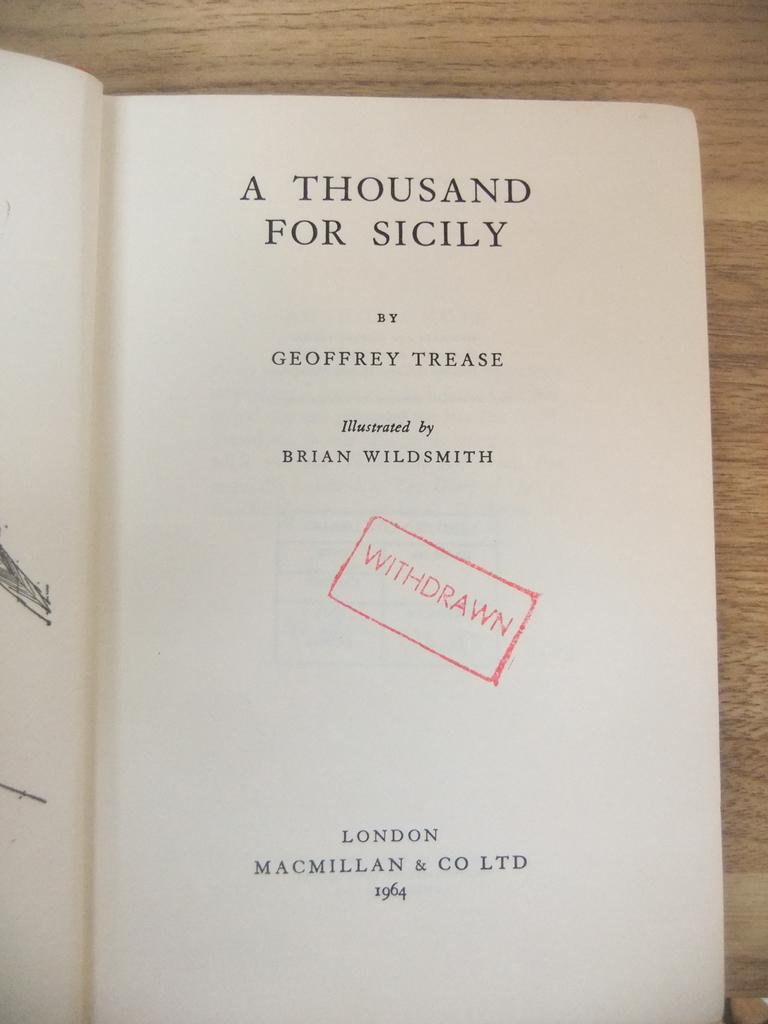<image>
Render a clear and concise summary of the photo. Book about A thousand for Sicily by Geoffrey Trease with the word Withdrawn in big red letters lies on a table. 